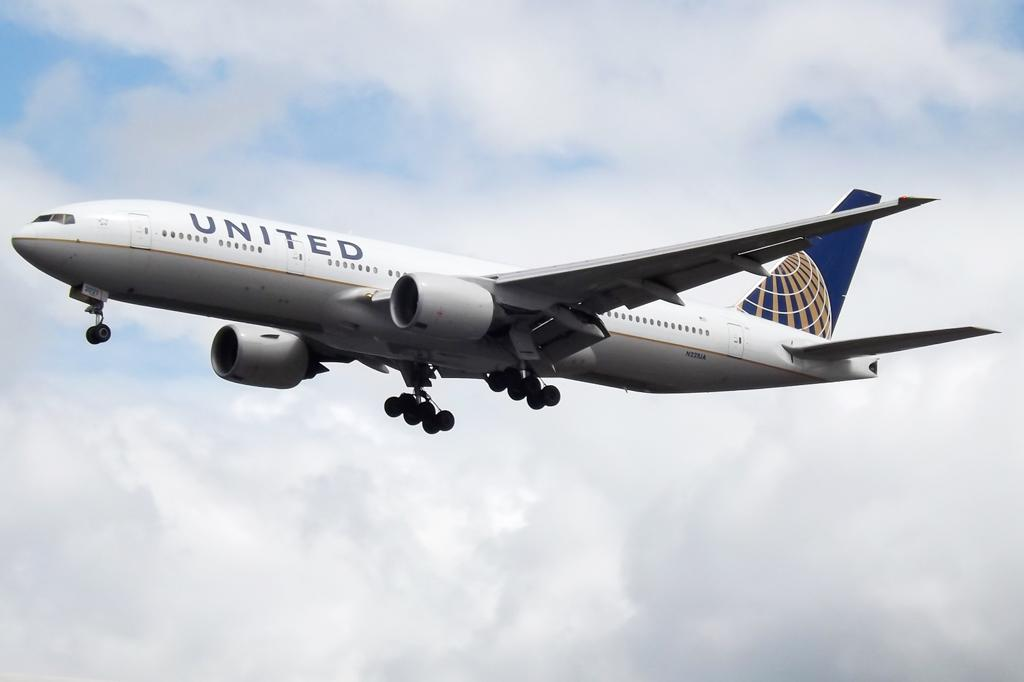<image>
Describe the image concisely. United Airplanes is flying in the air by itself 